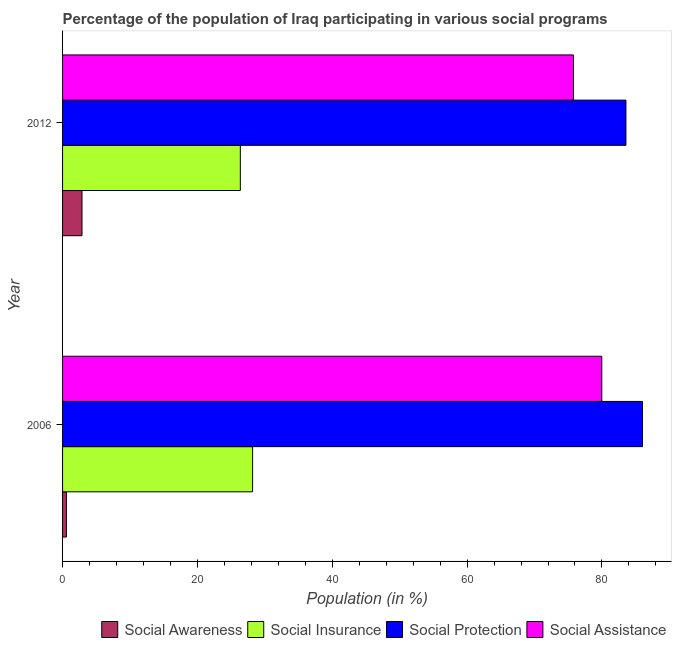Are the number of bars on each tick of the Y-axis equal?
Your answer should be compact. Yes. How many bars are there on the 1st tick from the top?
Offer a terse response. 4. What is the participation of population in social assistance programs in 2006?
Provide a short and direct response. 79.97. Across all years, what is the maximum participation of population in social assistance programs?
Make the answer very short. 79.97. Across all years, what is the minimum participation of population in social protection programs?
Give a very brief answer. 83.56. In which year was the participation of population in social assistance programs maximum?
Ensure brevity in your answer.  2006. In which year was the participation of population in social assistance programs minimum?
Make the answer very short. 2012. What is the total participation of population in social awareness programs in the graph?
Offer a very short reply. 3.45. What is the difference between the participation of population in social assistance programs in 2006 and that in 2012?
Offer a very short reply. 4.2. What is the difference between the participation of population in social insurance programs in 2006 and the participation of population in social protection programs in 2012?
Make the answer very short. -55.37. What is the average participation of population in social assistance programs per year?
Ensure brevity in your answer.  77.87. In the year 2006, what is the difference between the participation of population in social insurance programs and participation of population in social protection programs?
Provide a short and direct response. -57.83. What is the ratio of the participation of population in social assistance programs in 2006 to that in 2012?
Provide a short and direct response. 1.05. Is the difference between the participation of population in social protection programs in 2006 and 2012 greater than the difference between the participation of population in social assistance programs in 2006 and 2012?
Provide a short and direct response. No. In how many years, is the participation of population in social assistance programs greater than the average participation of population in social assistance programs taken over all years?
Give a very brief answer. 1. Is it the case that in every year, the sum of the participation of population in social insurance programs and participation of population in social awareness programs is greater than the sum of participation of population in social assistance programs and participation of population in social protection programs?
Your answer should be compact. No. What does the 2nd bar from the top in 2006 represents?
Make the answer very short. Social Protection. What does the 3rd bar from the bottom in 2012 represents?
Keep it short and to the point. Social Protection. Is it the case that in every year, the sum of the participation of population in social awareness programs and participation of population in social insurance programs is greater than the participation of population in social protection programs?
Ensure brevity in your answer.  No. Are all the bars in the graph horizontal?
Give a very brief answer. Yes. How many years are there in the graph?
Give a very brief answer. 2. Are the values on the major ticks of X-axis written in scientific E-notation?
Give a very brief answer. No. What is the title of the graph?
Offer a very short reply. Percentage of the population of Iraq participating in various social programs . What is the label or title of the X-axis?
Your answer should be compact. Population (in %). What is the label or title of the Y-axis?
Your answer should be compact. Year. What is the Population (in %) in Social Awareness in 2006?
Your answer should be very brief. 0.57. What is the Population (in %) of Social Insurance in 2006?
Your answer should be very brief. 28.19. What is the Population (in %) of Social Protection in 2006?
Offer a very short reply. 86.01. What is the Population (in %) in Social Assistance in 2006?
Your answer should be compact. 79.97. What is the Population (in %) in Social Awareness in 2012?
Provide a succinct answer. 2.88. What is the Population (in %) of Social Insurance in 2012?
Ensure brevity in your answer.  26.36. What is the Population (in %) in Social Protection in 2012?
Your answer should be compact. 83.56. What is the Population (in %) of Social Assistance in 2012?
Offer a very short reply. 75.77. Across all years, what is the maximum Population (in %) of Social Awareness?
Your answer should be compact. 2.88. Across all years, what is the maximum Population (in %) of Social Insurance?
Ensure brevity in your answer.  28.19. Across all years, what is the maximum Population (in %) in Social Protection?
Provide a succinct answer. 86.01. Across all years, what is the maximum Population (in %) in Social Assistance?
Provide a succinct answer. 79.97. Across all years, what is the minimum Population (in %) in Social Awareness?
Offer a terse response. 0.57. Across all years, what is the minimum Population (in %) of Social Insurance?
Give a very brief answer. 26.36. Across all years, what is the minimum Population (in %) in Social Protection?
Give a very brief answer. 83.56. Across all years, what is the minimum Population (in %) of Social Assistance?
Provide a succinct answer. 75.77. What is the total Population (in %) in Social Awareness in the graph?
Your answer should be very brief. 3.45. What is the total Population (in %) of Social Insurance in the graph?
Make the answer very short. 54.55. What is the total Population (in %) of Social Protection in the graph?
Provide a short and direct response. 169.57. What is the total Population (in %) of Social Assistance in the graph?
Your response must be concise. 155.75. What is the difference between the Population (in %) in Social Awareness in 2006 and that in 2012?
Keep it short and to the point. -2.31. What is the difference between the Population (in %) in Social Insurance in 2006 and that in 2012?
Your response must be concise. 1.82. What is the difference between the Population (in %) in Social Protection in 2006 and that in 2012?
Your answer should be compact. 2.45. What is the difference between the Population (in %) of Social Assistance in 2006 and that in 2012?
Keep it short and to the point. 4.2. What is the difference between the Population (in %) of Social Awareness in 2006 and the Population (in %) of Social Insurance in 2012?
Make the answer very short. -25.79. What is the difference between the Population (in %) in Social Awareness in 2006 and the Population (in %) in Social Protection in 2012?
Your answer should be very brief. -82.99. What is the difference between the Population (in %) of Social Awareness in 2006 and the Population (in %) of Social Assistance in 2012?
Keep it short and to the point. -75.2. What is the difference between the Population (in %) in Social Insurance in 2006 and the Population (in %) in Social Protection in 2012?
Your answer should be compact. -55.37. What is the difference between the Population (in %) of Social Insurance in 2006 and the Population (in %) of Social Assistance in 2012?
Your answer should be compact. -47.59. What is the difference between the Population (in %) in Social Protection in 2006 and the Population (in %) in Social Assistance in 2012?
Offer a very short reply. 10.24. What is the average Population (in %) in Social Awareness per year?
Offer a very short reply. 1.73. What is the average Population (in %) in Social Insurance per year?
Provide a succinct answer. 27.27. What is the average Population (in %) of Social Protection per year?
Your answer should be compact. 84.79. What is the average Population (in %) in Social Assistance per year?
Your answer should be very brief. 77.87. In the year 2006, what is the difference between the Population (in %) of Social Awareness and Population (in %) of Social Insurance?
Give a very brief answer. -27.61. In the year 2006, what is the difference between the Population (in %) of Social Awareness and Population (in %) of Social Protection?
Your answer should be compact. -85.44. In the year 2006, what is the difference between the Population (in %) in Social Awareness and Population (in %) in Social Assistance?
Your answer should be very brief. -79.4. In the year 2006, what is the difference between the Population (in %) of Social Insurance and Population (in %) of Social Protection?
Your response must be concise. -57.83. In the year 2006, what is the difference between the Population (in %) in Social Insurance and Population (in %) in Social Assistance?
Ensure brevity in your answer.  -51.79. In the year 2006, what is the difference between the Population (in %) in Social Protection and Population (in %) in Social Assistance?
Provide a short and direct response. 6.04. In the year 2012, what is the difference between the Population (in %) in Social Awareness and Population (in %) in Social Insurance?
Your response must be concise. -23.48. In the year 2012, what is the difference between the Population (in %) in Social Awareness and Population (in %) in Social Protection?
Give a very brief answer. -80.68. In the year 2012, what is the difference between the Population (in %) in Social Awareness and Population (in %) in Social Assistance?
Keep it short and to the point. -72.89. In the year 2012, what is the difference between the Population (in %) in Social Insurance and Population (in %) in Social Protection?
Ensure brevity in your answer.  -57.2. In the year 2012, what is the difference between the Population (in %) of Social Insurance and Population (in %) of Social Assistance?
Provide a short and direct response. -49.41. In the year 2012, what is the difference between the Population (in %) in Social Protection and Population (in %) in Social Assistance?
Offer a very short reply. 7.79. What is the ratio of the Population (in %) of Social Awareness in 2006 to that in 2012?
Your answer should be very brief. 0.2. What is the ratio of the Population (in %) of Social Insurance in 2006 to that in 2012?
Ensure brevity in your answer.  1.07. What is the ratio of the Population (in %) of Social Protection in 2006 to that in 2012?
Offer a very short reply. 1.03. What is the ratio of the Population (in %) in Social Assistance in 2006 to that in 2012?
Offer a terse response. 1.06. What is the difference between the highest and the second highest Population (in %) in Social Awareness?
Your response must be concise. 2.31. What is the difference between the highest and the second highest Population (in %) of Social Insurance?
Keep it short and to the point. 1.82. What is the difference between the highest and the second highest Population (in %) of Social Protection?
Keep it short and to the point. 2.45. What is the difference between the highest and the second highest Population (in %) of Social Assistance?
Provide a succinct answer. 4.2. What is the difference between the highest and the lowest Population (in %) of Social Awareness?
Keep it short and to the point. 2.31. What is the difference between the highest and the lowest Population (in %) in Social Insurance?
Provide a succinct answer. 1.82. What is the difference between the highest and the lowest Population (in %) in Social Protection?
Offer a very short reply. 2.45. What is the difference between the highest and the lowest Population (in %) in Social Assistance?
Ensure brevity in your answer.  4.2. 